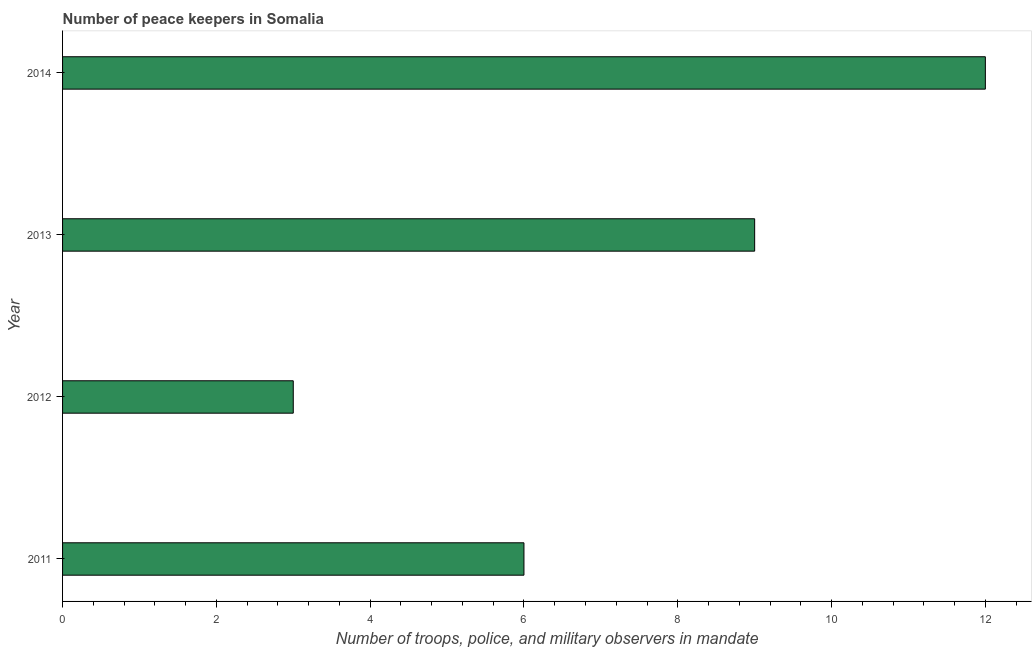What is the title of the graph?
Offer a terse response. Number of peace keepers in Somalia. What is the label or title of the X-axis?
Provide a succinct answer. Number of troops, police, and military observers in mandate. What is the label or title of the Y-axis?
Provide a succinct answer. Year. What is the number of peace keepers in 2014?
Offer a terse response. 12. Across all years, what is the maximum number of peace keepers?
Keep it short and to the point. 12. Across all years, what is the minimum number of peace keepers?
Give a very brief answer. 3. What is the difference between the number of peace keepers in 2011 and 2012?
Offer a very short reply. 3. What is the median number of peace keepers?
Your response must be concise. 7.5. In how many years, is the number of peace keepers greater than 3.2 ?
Your answer should be compact. 3. What is the ratio of the number of peace keepers in 2012 to that in 2014?
Make the answer very short. 0.25. Is the sum of the number of peace keepers in 2012 and 2014 greater than the maximum number of peace keepers across all years?
Provide a short and direct response. Yes. What is the difference between the highest and the lowest number of peace keepers?
Give a very brief answer. 9. What is the difference between two consecutive major ticks on the X-axis?
Provide a succinct answer. 2. Are the values on the major ticks of X-axis written in scientific E-notation?
Give a very brief answer. No. What is the Number of troops, police, and military observers in mandate of 2012?
Give a very brief answer. 3. What is the difference between the Number of troops, police, and military observers in mandate in 2011 and 2014?
Give a very brief answer. -6. What is the difference between the Number of troops, police, and military observers in mandate in 2012 and 2013?
Provide a succinct answer. -6. What is the difference between the Number of troops, police, and military observers in mandate in 2012 and 2014?
Your response must be concise. -9. What is the difference between the Number of troops, police, and military observers in mandate in 2013 and 2014?
Provide a succinct answer. -3. What is the ratio of the Number of troops, police, and military observers in mandate in 2011 to that in 2013?
Your answer should be very brief. 0.67. What is the ratio of the Number of troops, police, and military observers in mandate in 2011 to that in 2014?
Keep it short and to the point. 0.5. What is the ratio of the Number of troops, police, and military observers in mandate in 2012 to that in 2013?
Provide a short and direct response. 0.33. What is the ratio of the Number of troops, police, and military observers in mandate in 2012 to that in 2014?
Keep it short and to the point. 0.25. 